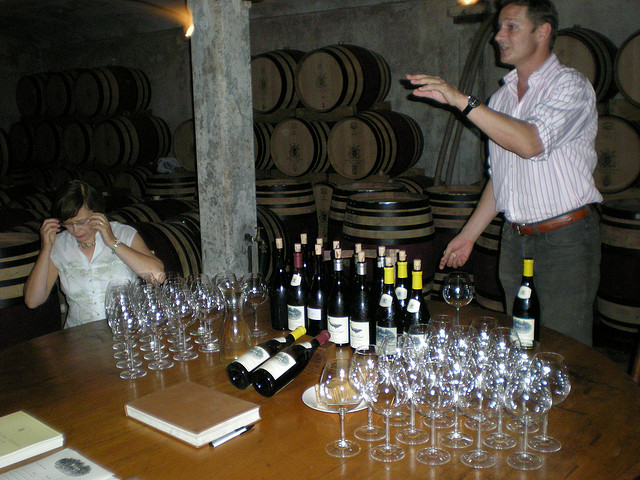Is there anything in the image that can provide hints about the location of this winery? While specific location details aren't visible, the style of the cellar with rows of oak barrels and the type of bottles suggest it could be a winery in a region known for its aged wines, such as those found in France, Italy, or Spain. The design of the room, with its vaulted ceilings and rustic ambiance, adds to the European aesthetic. However, without visible geographic indicators or recognizable bottle labels, an exact location can't be determined from the image alone. 